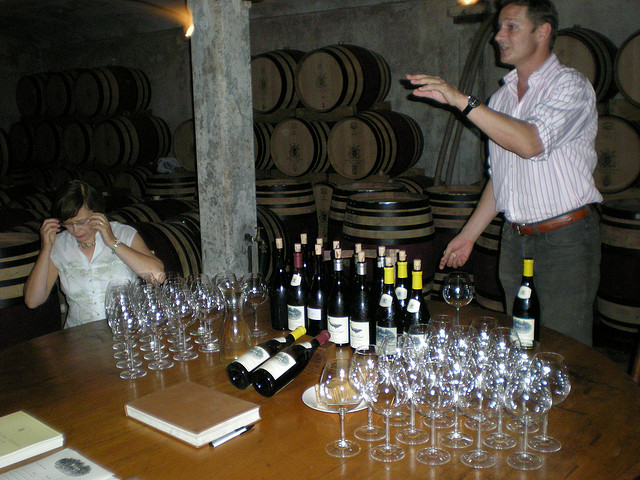Is there anything in the image that can provide hints about the location of this winery? While specific location details aren't visible, the style of the cellar with rows of oak barrels and the type of bottles suggest it could be a winery in a region known for its aged wines, such as those found in France, Italy, or Spain. The design of the room, with its vaulted ceilings and rustic ambiance, adds to the European aesthetic. However, without visible geographic indicators or recognizable bottle labels, an exact location can't be determined from the image alone. 